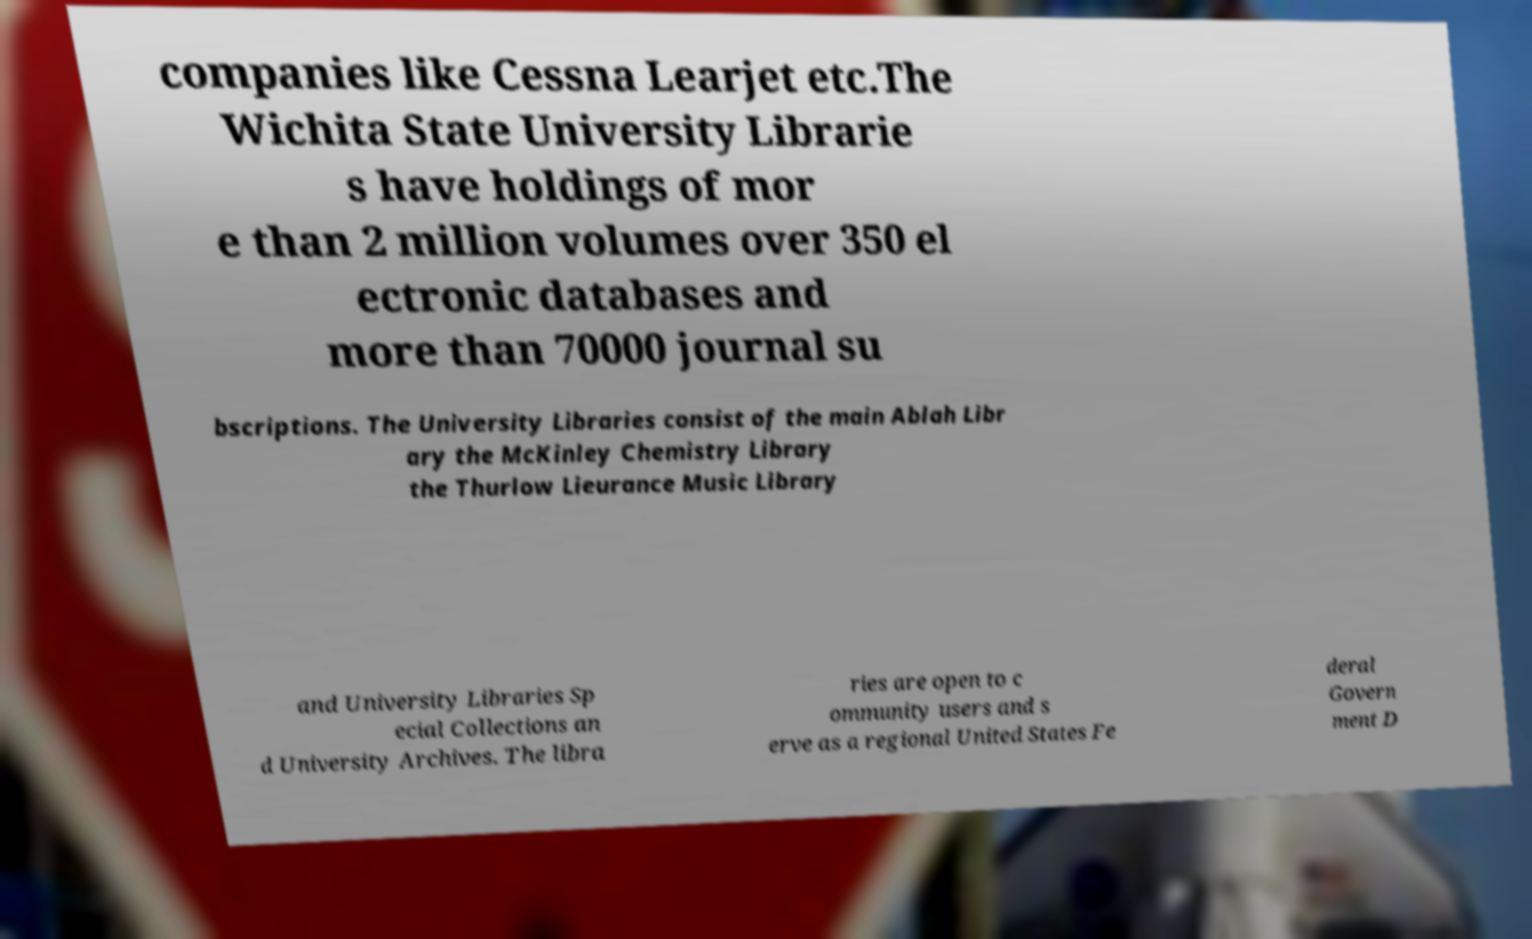Please read and relay the text visible in this image. What does it say? companies like Cessna Learjet etc.The Wichita State University Librarie s have holdings of mor e than 2 million volumes over 350 el ectronic databases and more than 70000 journal su bscriptions. The University Libraries consist of the main Ablah Libr ary the McKinley Chemistry Library the Thurlow Lieurance Music Library and University Libraries Sp ecial Collections an d University Archives. The libra ries are open to c ommunity users and s erve as a regional United States Fe deral Govern ment D 